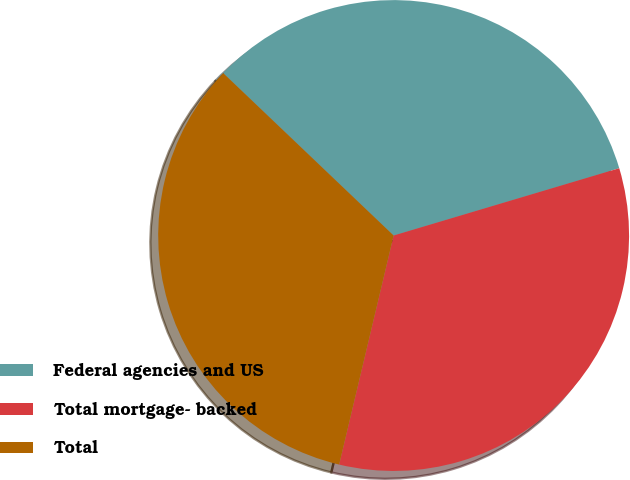Convert chart to OTSL. <chart><loc_0><loc_0><loc_500><loc_500><pie_chart><fcel>Federal agencies and US<fcel>Total mortgage- backed<fcel>Total<nl><fcel>33.27%<fcel>33.33%<fcel>33.4%<nl></chart> 